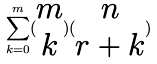<formula> <loc_0><loc_0><loc_500><loc_500>\sum _ { k = 0 } ^ { m } ( \begin{matrix} m \\ k \end{matrix} ) ( \begin{matrix} n \\ r + k \end{matrix} )</formula> 